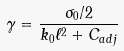<formula> <loc_0><loc_0><loc_500><loc_500>\gamma = \frac { \sigma _ { 0 } / 2 } { k _ { 0 } \ell ^ { 2 } + C _ { a d j } }</formula> 